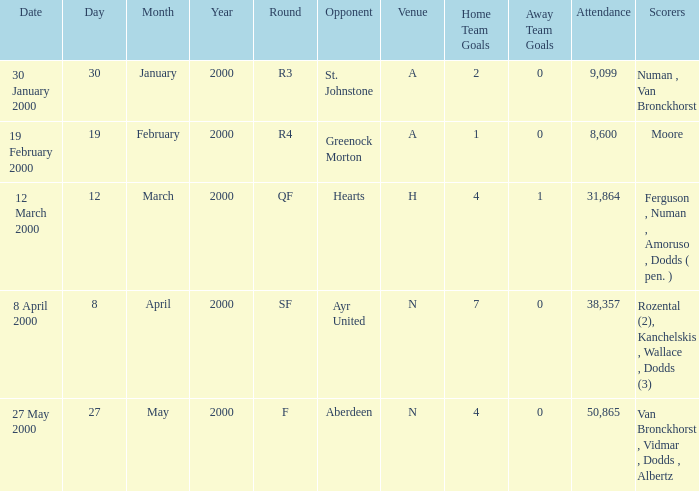Who was on 12 March 2000? Ferguson , Numan , Amoruso , Dodds ( pen. ). 